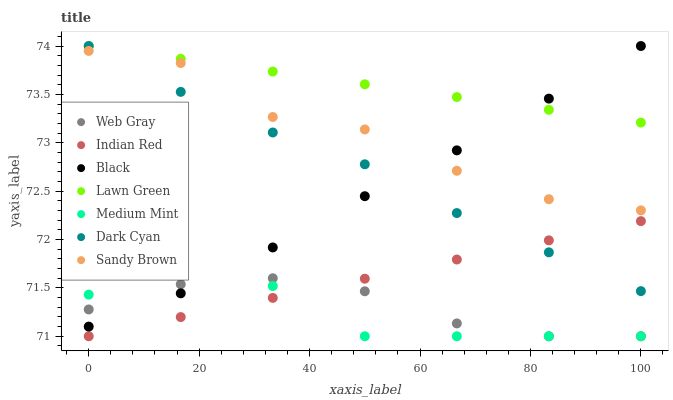Does Medium Mint have the minimum area under the curve?
Answer yes or no. Yes. Does Lawn Green have the maximum area under the curve?
Answer yes or no. Yes. Does Web Gray have the minimum area under the curve?
Answer yes or no. No. Does Web Gray have the maximum area under the curve?
Answer yes or no. No. Is Indian Red the smoothest?
Answer yes or no. Yes. Is Sandy Brown the roughest?
Answer yes or no. Yes. Is Lawn Green the smoothest?
Answer yes or no. No. Is Lawn Green the roughest?
Answer yes or no. No. Does Medium Mint have the lowest value?
Answer yes or no. Yes. Does Lawn Green have the lowest value?
Answer yes or no. No. Does Dark Cyan have the highest value?
Answer yes or no. Yes. Does Web Gray have the highest value?
Answer yes or no. No. Is Web Gray less than Lawn Green?
Answer yes or no. Yes. Is Black greater than Indian Red?
Answer yes or no. Yes. Does Medium Mint intersect Black?
Answer yes or no. Yes. Is Medium Mint less than Black?
Answer yes or no. No. Is Medium Mint greater than Black?
Answer yes or no. No. Does Web Gray intersect Lawn Green?
Answer yes or no. No. 